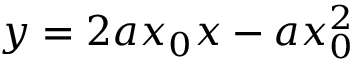Convert formula to latex. <formula><loc_0><loc_0><loc_500><loc_500>y = 2 a x _ { 0 } x - a x _ { 0 } ^ { 2 }</formula> 